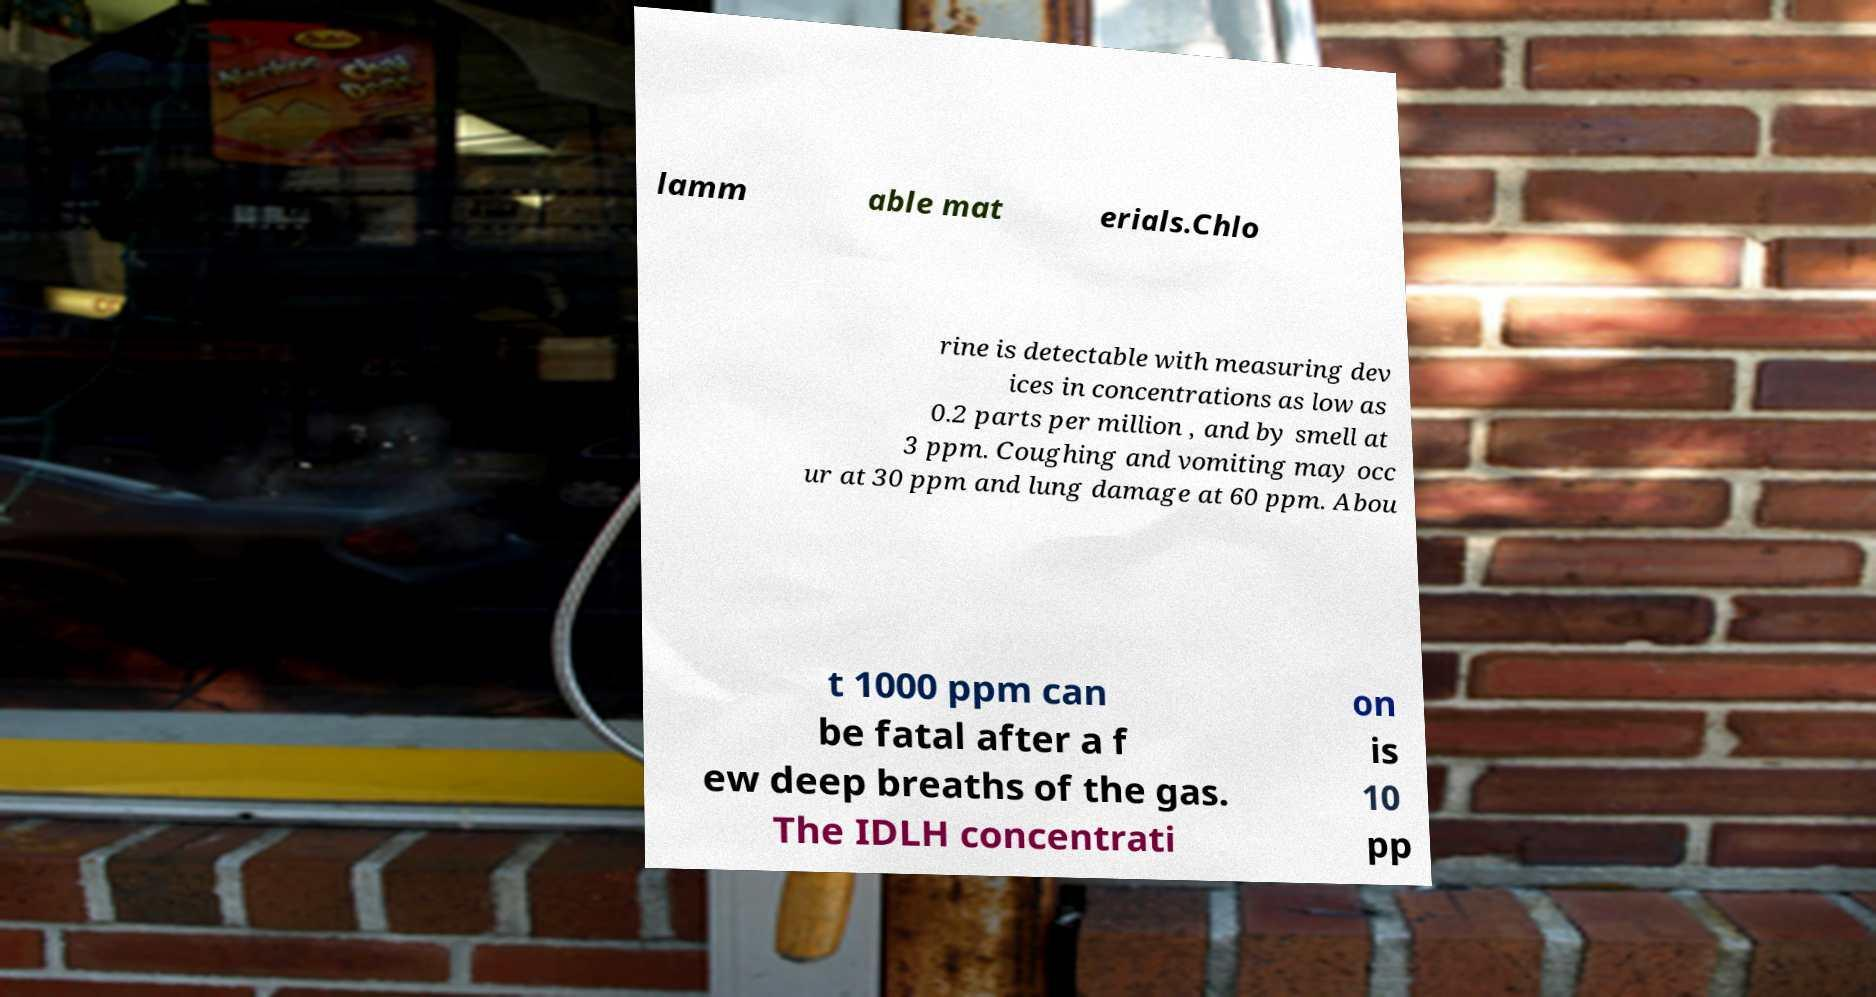Please read and relay the text visible in this image. What does it say? lamm able mat erials.Chlo rine is detectable with measuring dev ices in concentrations as low as 0.2 parts per million , and by smell at 3 ppm. Coughing and vomiting may occ ur at 30 ppm and lung damage at 60 ppm. Abou t 1000 ppm can be fatal after a f ew deep breaths of the gas. The IDLH concentrati on is 10 pp 